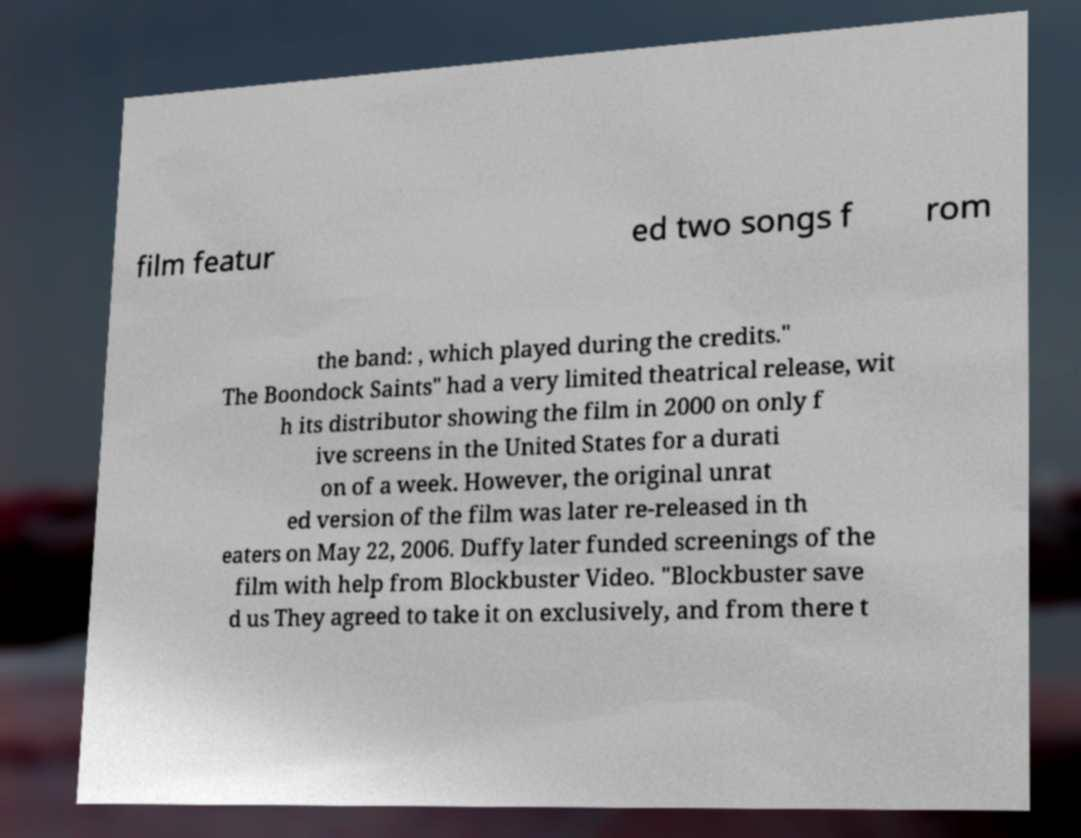Can you accurately transcribe the text from the provided image for me? film featur ed two songs f rom the band: , which played during the credits." The Boondock Saints" had a very limited theatrical release, wit h its distributor showing the film in 2000 on only f ive screens in the United States for a durati on of a week. However, the original unrat ed version of the film was later re-released in th eaters on May 22, 2006. Duffy later funded screenings of the film with help from Blockbuster Video. "Blockbuster save d us They agreed to take it on exclusively, and from there t 